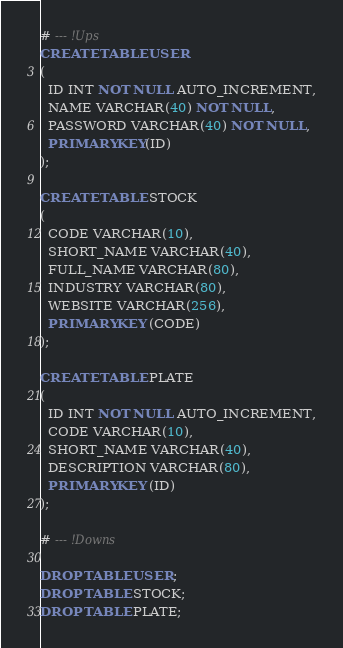<code> <loc_0><loc_0><loc_500><loc_500><_SQL_># --- !Ups
CREATE TABLE USER
(
  ID INT NOT NULL AUTO_INCREMENT,
  NAME VARCHAR(40) NOT NULL,
  PASSWORD VARCHAR(40) NOT NULL,
  PRIMARY KEY(ID)
);

CREATE TABLE STOCK
(
  CODE VARCHAR(10),
  SHORT_NAME VARCHAR(40),
  FULL_NAME VARCHAR(80),
  INDUSTRY VARCHAR(80),
  WEBSITE VARCHAR(256),
  PRIMARY KEY (CODE)
);

CREATE TABLE PLATE
(
  ID INT NOT NULL AUTO_INCREMENT,
  CODE VARCHAR(10),
  SHORT_NAME VARCHAR(40),
  DESCRIPTION VARCHAR(80),
  PRIMARY KEY (ID)
);

# --- !Downs

DROP TABLE USER;
DROP TABLE STOCK;
DROP TABLE PLATE;
</code> 